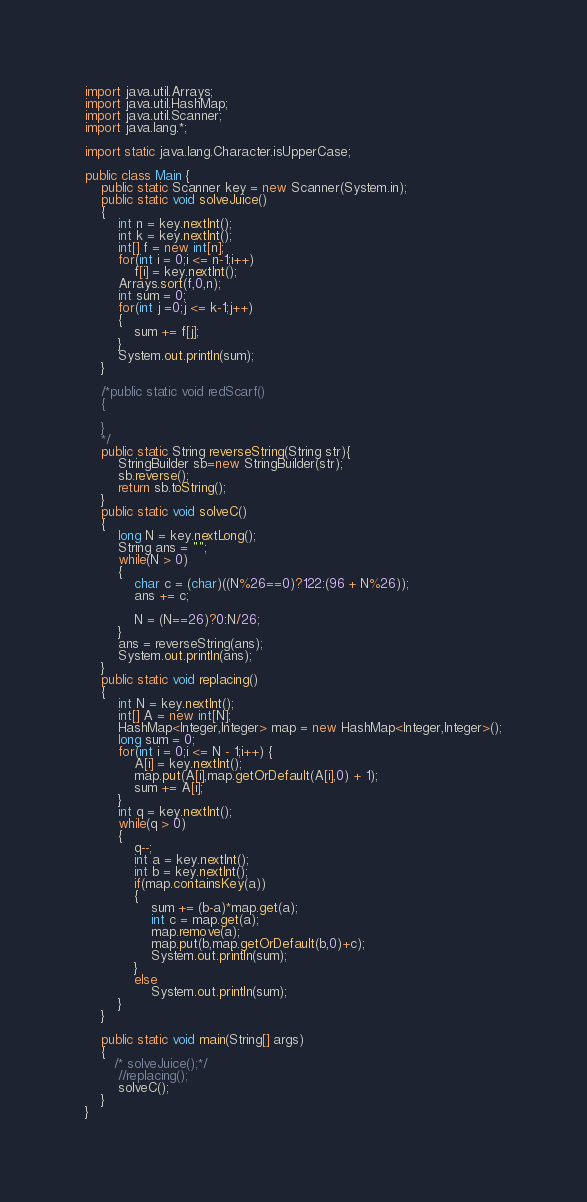<code> <loc_0><loc_0><loc_500><loc_500><_Java_>
import java.util.Arrays;
import java.util.HashMap;
import java.util.Scanner;
import java.lang.*;

import static java.lang.Character.isUpperCase;

public class Main {
    public static Scanner key = new Scanner(System.in);
    public static void solveJuice()
    {
        int n = key.nextInt();
        int k = key.nextInt();
        int[] f = new int[n];
        for(int i = 0;i <= n-1;i++)
            f[i] = key.nextInt();
        Arrays.sort(f,0,n);
        int sum = 0;
        for(int j =0;j <= k-1;j++)
        {
            sum += f[j];
        }
        System.out.println(sum);
    }

    /*public static void redScarf()
    {

    }
    */
    public static String reverseString(String str){
        StringBuilder sb=new StringBuilder(str);
        sb.reverse();
        return sb.toString();
    }
    public static void solveC()
    {
        long N = key.nextLong();
        String ans = "";
        while(N > 0)
        {
            char c = (char)((N%26==0)?122:(96 + N%26));
            ans += c;

            N = (N==26)?0:N/26;
        }
        ans = reverseString(ans);
        System.out.println(ans);
    }
    public static void replacing()
    {
        int N = key.nextInt();
        int[] A = new int[N];
        HashMap<Integer,Integer> map = new HashMap<Integer,Integer>();
        long sum = 0;
        for(int i = 0;i <= N - 1;i++) {
            A[i] = key.nextInt();
            map.put(A[i],map.getOrDefault(A[i],0) + 1);
            sum += A[i];
        }
        int q = key.nextInt();
        while(q > 0)
        {
            q--;
            int a = key.nextInt();
            int b = key.nextInt();
            if(map.containsKey(a))
            {
                sum += (b-a)*map.get(a);
                int c = map.get(a);
                map.remove(a);
                map.put(b,map.getOrDefault(b,0)+c);
                System.out.println(sum);
            }
            else
                System.out.println(sum);
        }
    }

    public static void main(String[] args)
    {
       /* solveJuice();*/
        //replacing();
        solveC();
    }
}
</code> 